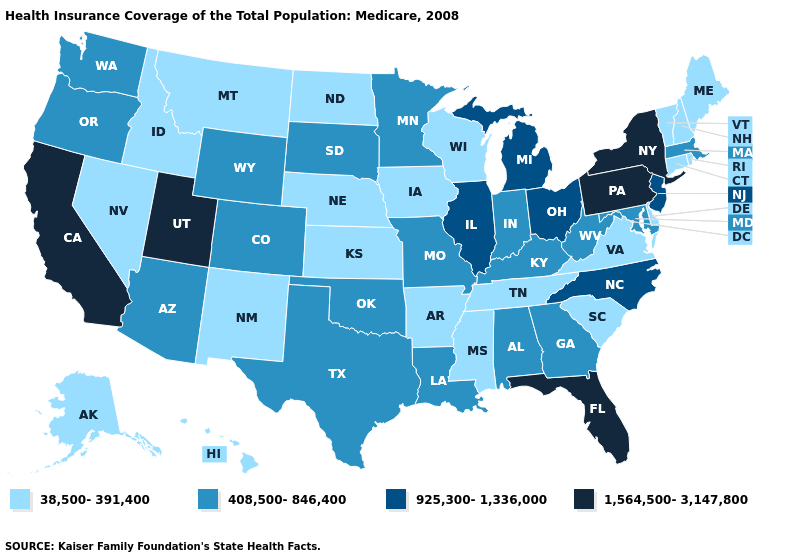What is the value of Washington?
Concise answer only. 408,500-846,400. Does Illinois have a higher value than Florida?
Write a very short answer. No. Name the states that have a value in the range 408,500-846,400?
Answer briefly. Alabama, Arizona, Colorado, Georgia, Indiana, Kentucky, Louisiana, Maryland, Massachusetts, Minnesota, Missouri, Oklahoma, Oregon, South Dakota, Texas, Washington, West Virginia, Wyoming. What is the lowest value in the MidWest?
Be succinct. 38,500-391,400. Name the states that have a value in the range 925,300-1,336,000?
Quick response, please. Illinois, Michigan, New Jersey, North Carolina, Ohio. Name the states that have a value in the range 1,564,500-3,147,800?
Write a very short answer. California, Florida, New York, Pennsylvania, Utah. Does Montana have the lowest value in the West?
Keep it brief. Yes. Among the states that border Idaho , which have the lowest value?
Be succinct. Montana, Nevada. Which states hav the highest value in the Northeast?
Concise answer only. New York, Pennsylvania. Which states have the highest value in the USA?
Concise answer only. California, Florida, New York, Pennsylvania, Utah. What is the lowest value in the South?
Quick response, please. 38,500-391,400. What is the highest value in the USA?
Answer briefly. 1,564,500-3,147,800. Does Ohio have the highest value in the USA?
Write a very short answer. No. What is the value of Nebraska?
Give a very brief answer. 38,500-391,400. 